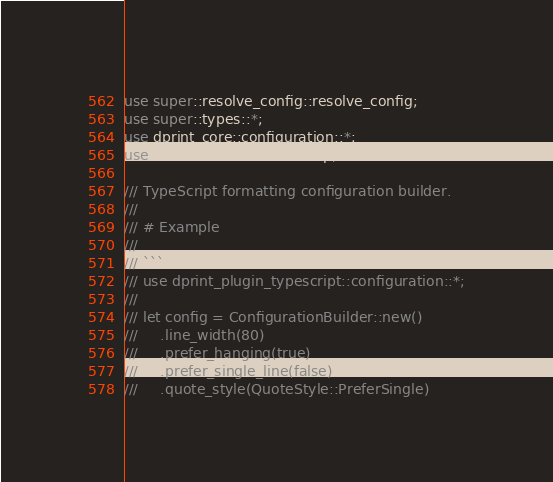Convert code to text. <code><loc_0><loc_0><loc_500><loc_500><_Rust_>use super::resolve_config::resolve_config;
use super::types::*;
use dprint_core::configuration::*;
use std::collections::HashMap;

/// TypeScript formatting configuration builder.
///
/// # Example
///
/// ```
/// use dprint_plugin_typescript::configuration::*;
///
/// let config = ConfigurationBuilder::new()
///     .line_width(80)
///     .prefer_hanging(true)
///     .prefer_single_line(false)
///     .quote_style(QuoteStyle::PreferSingle)</code> 